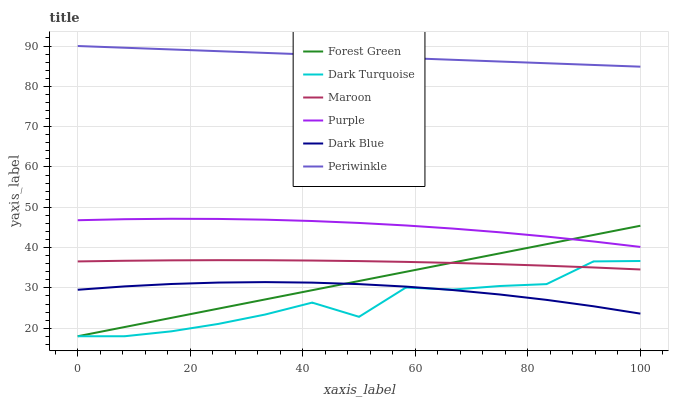Does Dark Turquoise have the minimum area under the curve?
Answer yes or no. Yes. Does Periwinkle have the maximum area under the curve?
Answer yes or no. Yes. Does Maroon have the minimum area under the curve?
Answer yes or no. No. Does Maroon have the maximum area under the curve?
Answer yes or no. No. Is Periwinkle the smoothest?
Answer yes or no. Yes. Is Dark Turquoise the roughest?
Answer yes or no. Yes. Is Maroon the smoothest?
Answer yes or no. No. Is Maroon the roughest?
Answer yes or no. No. Does Dark Turquoise have the lowest value?
Answer yes or no. Yes. Does Maroon have the lowest value?
Answer yes or no. No. Does Periwinkle have the highest value?
Answer yes or no. Yes. Does Dark Turquoise have the highest value?
Answer yes or no. No. Is Maroon less than Purple?
Answer yes or no. Yes. Is Periwinkle greater than Forest Green?
Answer yes or no. Yes. Does Forest Green intersect Purple?
Answer yes or no. Yes. Is Forest Green less than Purple?
Answer yes or no. No. Is Forest Green greater than Purple?
Answer yes or no. No. Does Maroon intersect Purple?
Answer yes or no. No. 